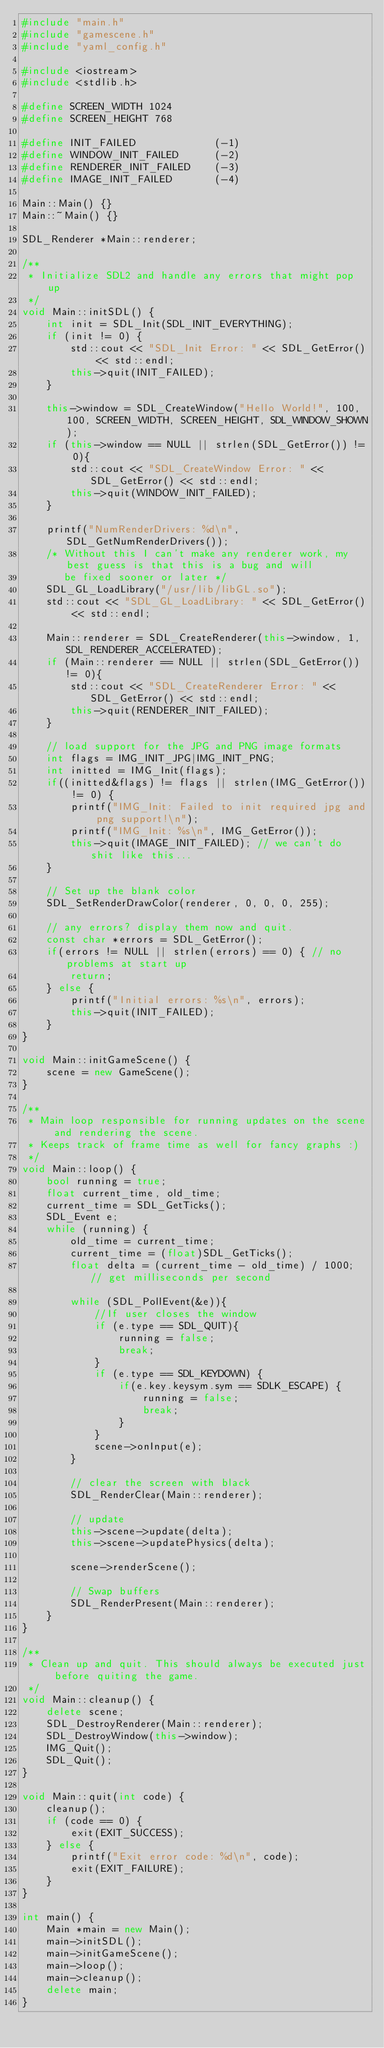<code> <loc_0><loc_0><loc_500><loc_500><_C++_>#include "main.h"
#include "gamescene.h"
#include "yaml_config.h"

#include <iostream>
#include <stdlib.h>

#define SCREEN_WIDTH 1024
#define SCREEN_HEIGHT 768

#define INIT_FAILED             (-1)
#define WINDOW_INIT_FAILED      (-2)
#define RENDERER_INIT_FAILED    (-3)
#define IMAGE_INIT_FAILED       (-4)

Main::Main() {}
Main::~Main() {}

SDL_Renderer *Main::renderer;

/**
 * Initialize SDL2 and handle any errors that might pop up
 */
void Main::initSDL() {
    int init = SDL_Init(SDL_INIT_EVERYTHING);
    if (init != 0) {
        std::cout << "SDL_Init Error: " << SDL_GetError() << std::endl;
        this->quit(INIT_FAILED);
    }

    this->window = SDL_CreateWindow("Hello World!", 100, 100, SCREEN_WIDTH, SCREEN_HEIGHT, SDL_WINDOW_SHOWN);
    if (this->window == NULL || strlen(SDL_GetError()) != 0){
        std::cout << "SDL_CreateWindow Error: " << SDL_GetError() << std::endl;
        this->quit(WINDOW_INIT_FAILED);
    }

    printf("NumRenderDrivers: %d\n", SDL_GetNumRenderDrivers());
    /* Without this I can't make any renderer work, my best guess is that this is a bug and will
       be fixed sooner or later */
    SDL_GL_LoadLibrary("/usr/lib/libGL.so");
    std::cout << "SDL_GL_LoadLibrary: " << SDL_GetError() << std::endl;
    
    Main::renderer = SDL_CreateRenderer(this->window, 1, SDL_RENDERER_ACCELERATED);
    if (Main::renderer == NULL || strlen(SDL_GetError()) != 0){
        std::cout << "SDL_CreateRenderer Error: " << SDL_GetError() << std::endl;
        this->quit(RENDERER_INIT_FAILED);
    }

    // load support for the JPG and PNG image formats
    int flags = IMG_INIT_JPG|IMG_INIT_PNG;
    int initted = IMG_Init(flags);
    if((initted&flags) != flags || strlen(IMG_GetError()) != 0) {
        printf("IMG_Init: Failed to init required jpg and png support!\n");
        printf("IMG_Init: %s\n", IMG_GetError());
        this->quit(IMAGE_INIT_FAILED); // we can't do shit like this...
    }

    // Set up the blank color
    SDL_SetRenderDrawColor(renderer, 0, 0, 0, 255);

    // any errors? display them now and quit.
    const char *errors = SDL_GetError();
    if(errors != NULL || strlen(errors) == 0) { // no problems at start up
        return;
    } else {
        printf("Initial errors: %s\n", errors);
        this->quit(INIT_FAILED);
    }
}

void Main::initGameScene() {
    scene = new GameScene();
}

/**
 * Main loop responsible for running updates on the scene and rendering the scene.
 * Keeps track of frame time as well for fancy graphs :)
 */
void Main::loop() {
    bool running = true;
    float current_time, old_time;
    current_time = SDL_GetTicks();
    SDL_Event e;
    while (running) {
        old_time = current_time;
        current_time = (float)SDL_GetTicks();
        float delta = (current_time - old_time) / 1000; // get milliseconds per second

        while (SDL_PollEvent(&e)){
            //If user closes the window
            if (e.type == SDL_QUIT){
                running = false;
                break;
            }
            if (e.type == SDL_KEYDOWN) {
                if(e.key.keysym.sym == SDLK_ESCAPE) {
                    running = false;
                    break;
                }
            }
            scene->onInput(e);
        }

        // clear the screen with black
        SDL_RenderClear(Main::renderer);

        // update
        this->scene->update(delta);
        this->scene->updatePhysics(delta);

        scene->renderScene();

        // Swap buffers
        SDL_RenderPresent(Main::renderer);
    }
}

/**
 * Clean up and quit. This should always be executed just before quiting the game.
 */
void Main::cleanup() {
    delete scene;
    SDL_DestroyRenderer(Main::renderer);
    SDL_DestroyWindow(this->window);
    IMG_Quit();
    SDL_Quit();
}

void Main::quit(int code) {
    cleanup();
    if (code == 0) {
        exit(EXIT_SUCCESS);
    } else {
        printf("Exit error code: %d\n", code);
        exit(EXIT_FAILURE);
    }
}

int main() {
    Main *main = new Main();
    main->initSDL();
    main->initGameScene();
    main->loop();
    main->cleanup();
    delete main;
}
</code> 